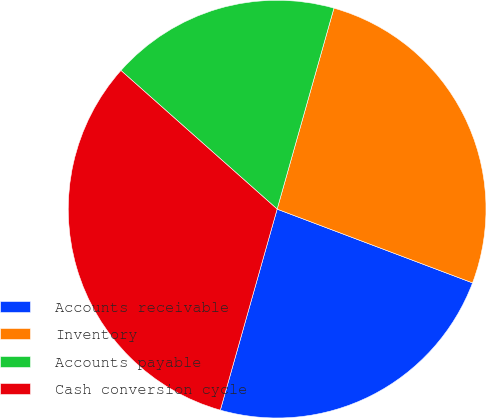<chart> <loc_0><loc_0><loc_500><loc_500><pie_chart><fcel>Accounts receivable<fcel>Inventory<fcel>Accounts payable<fcel>Cash conversion cycle<nl><fcel>23.64%<fcel>26.36%<fcel>17.83%<fcel>32.17%<nl></chart> 